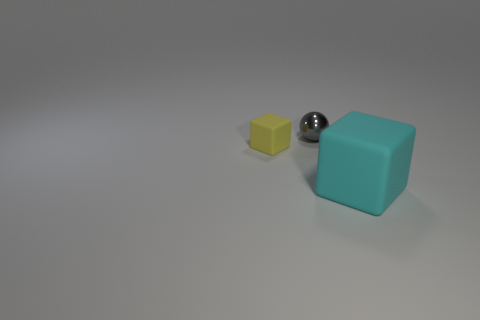Is there any other thing that has the same size as the cyan thing?
Your answer should be compact. No. There is a matte thing that is in front of the yellow rubber thing; how big is it?
Make the answer very short. Large. How many objects are either tiny green metal spheres or objects that are in front of the gray thing?
Offer a very short reply. 2. How many other objects are the same size as the yellow cube?
Make the answer very short. 1. What is the material of the big cyan thing that is the same shape as the tiny matte thing?
Offer a terse response. Rubber. Are there more small gray shiny objects that are left of the yellow thing than small cyan metallic cubes?
Offer a very short reply. No. Is there any other thing that has the same color as the small sphere?
Provide a succinct answer. No. What is the shape of the thing that is the same material as the big cyan block?
Keep it short and to the point. Cube. Do the gray thing on the left side of the big matte thing and the large cyan object have the same material?
Offer a terse response. No. Is the color of the rubber thing that is on the left side of the small metal sphere the same as the rubber thing to the right of the shiny sphere?
Make the answer very short. No. 